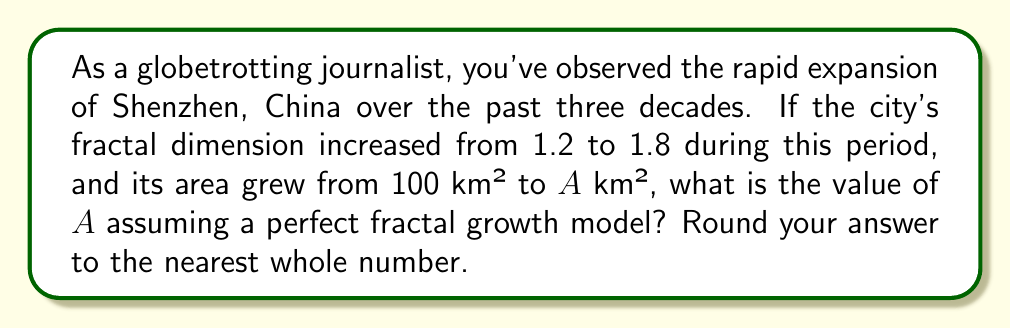Could you help me with this problem? To solve this problem, we'll use the relationship between fractal dimension, area, and scale factor. Let's approach this step-by-step:

1) The fractal dimension $D$ is related to the scale factor $r$ and the number of self-similar pieces $N$ by the equation:

   $$D = \frac{\log N}{\log r}$$

2) In our case, we have two time points with different fractal dimensions:
   - Initial: $D_1 = 1.2$, $A_1 = 100$ km²
   - Final: $D_2 = 1.8$, $A_2 = A$ km²

3) The scale factor $r$ is related to the areas by:

   $$r = \sqrt{\frac{A_2}{A_1}}$$

4) Substituting this into the fractal dimension equation:

   $$D_2 = \frac{\log N}{\log \sqrt{\frac{A_2}{A_1}}}$$

5) We can express $N$ in terms of areas and dimensions:

   $$N = \left(\frac{A_2}{A_1}\right)^{\frac{D_2}{2}}$$

6) Now, let's equate the two expressions for $N$:

   $$\left(\frac{A_2}{A_1}\right)^{\frac{D_1}{2}} = \left(\frac{A_2}{A_1}\right)^{\frac{D_2}{2}}$$

7) Simplifying:

   $$\left(\frac{A_2}{100}\right)^{0.6} = \left(\frac{A_2}{100}\right)^{0.9}$$

8) Taking the natural log of both sides:

   $$0.6 \ln\left(\frac{A_2}{100}\right) = 0.9 \ln\left(\frac{A_2}{100}\right)$$

9) Solving for $A_2$:

   $$\ln\left(\frac{A_2}{100}\right) = 0$$
   $$\frac{A_2}{100} = e^0 = 1$$
   $$A_2 = 100$$

Therefore, $A = 100$ km².
Answer: 100 km² 